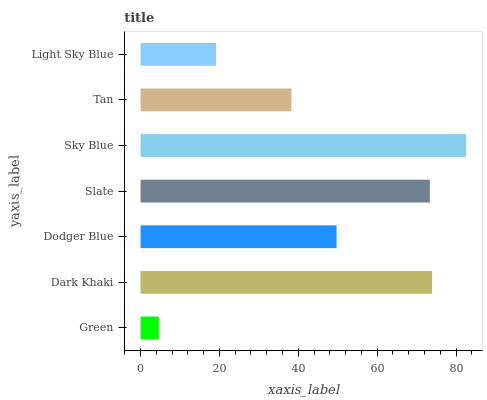Is Green the minimum?
Answer yes or no. Yes. Is Sky Blue the maximum?
Answer yes or no. Yes. Is Dark Khaki the minimum?
Answer yes or no. No. Is Dark Khaki the maximum?
Answer yes or no. No. Is Dark Khaki greater than Green?
Answer yes or no. Yes. Is Green less than Dark Khaki?
Answer yes or no. Yes. Is Green greater than Dark Khaki?
Answer yes or no. No. Is Dark Khaki less than Green?
Answer yes or no. No. Is Dodger Blue the high median?
Answer yes or no. Yes. Is Dodger Blue the low median?
Answer yes or no. Yes. Is Light Sky Blue the high median?
Answer yes or no. No. Is Sky Blue the low median?
Answer yes or no. No. 